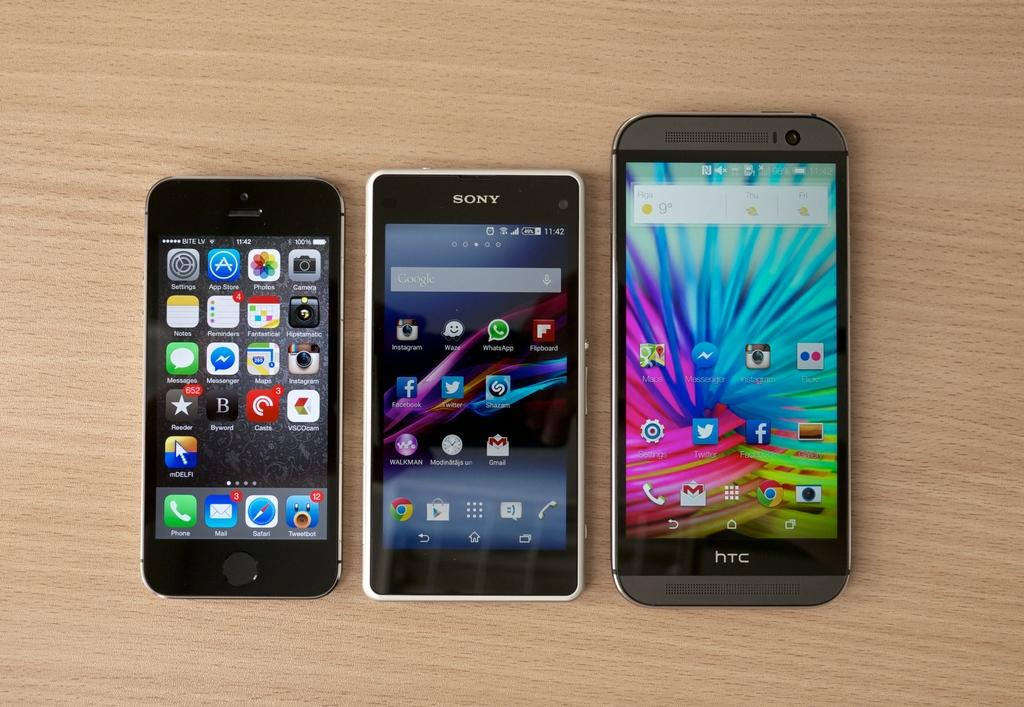<image>
Describe the image concisely. Sony is one of the brands shown among the three phones. 